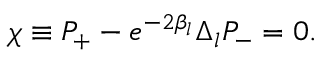Convert formula to latex. <formula><loc_0><loc_0><loc_500><loc_500>\chi \equiv P _ { + } - e ^ { - 2 \beta _ { l } } \Delta _ { l } P _ { - } = 0 .</formula> 